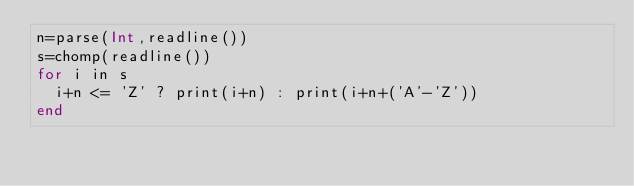Convert code to text. <code><loc_0><loc_0><loc_500><loc_500><_Julia_>n=parse(Int,readline())
s=chomp(readline())
for i in s
  i+n <= 'Z' ? print(i+n) : print(i+n+('A'-'Z'))
end</code> 